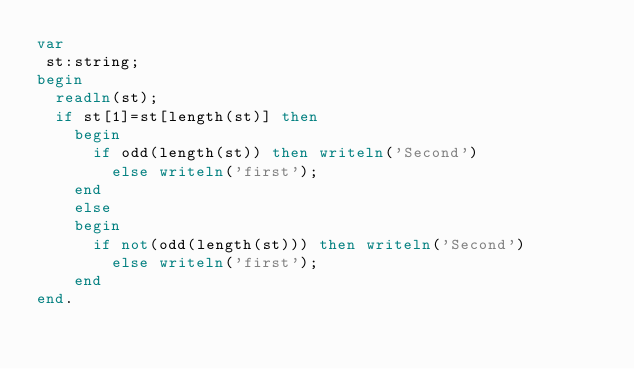Convert code to text. <code><loc_0><loc_0><loc_500><loc_500><_Pascal_>var
 st:string;
begin
  readln(st);
  if st[1]=st[length(st)] then
    begin
      if odd(length(st)) then writeln('Second')
        else writeln('first');
    end
    else 
    begin
      if not(odd(length(st))) then writeln('Second')
        else writeln('first');
    end
end.</code> 